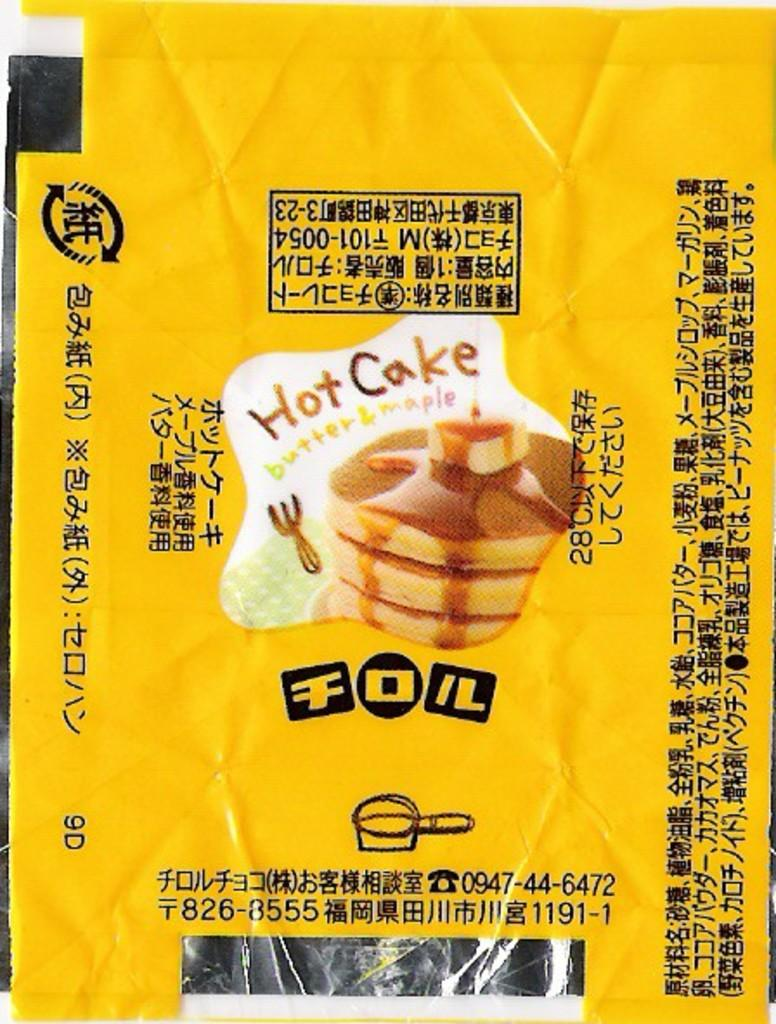<image>
Create a compact narrative representing the image presented. An advertisement for Hot Cakes with butter and maple 